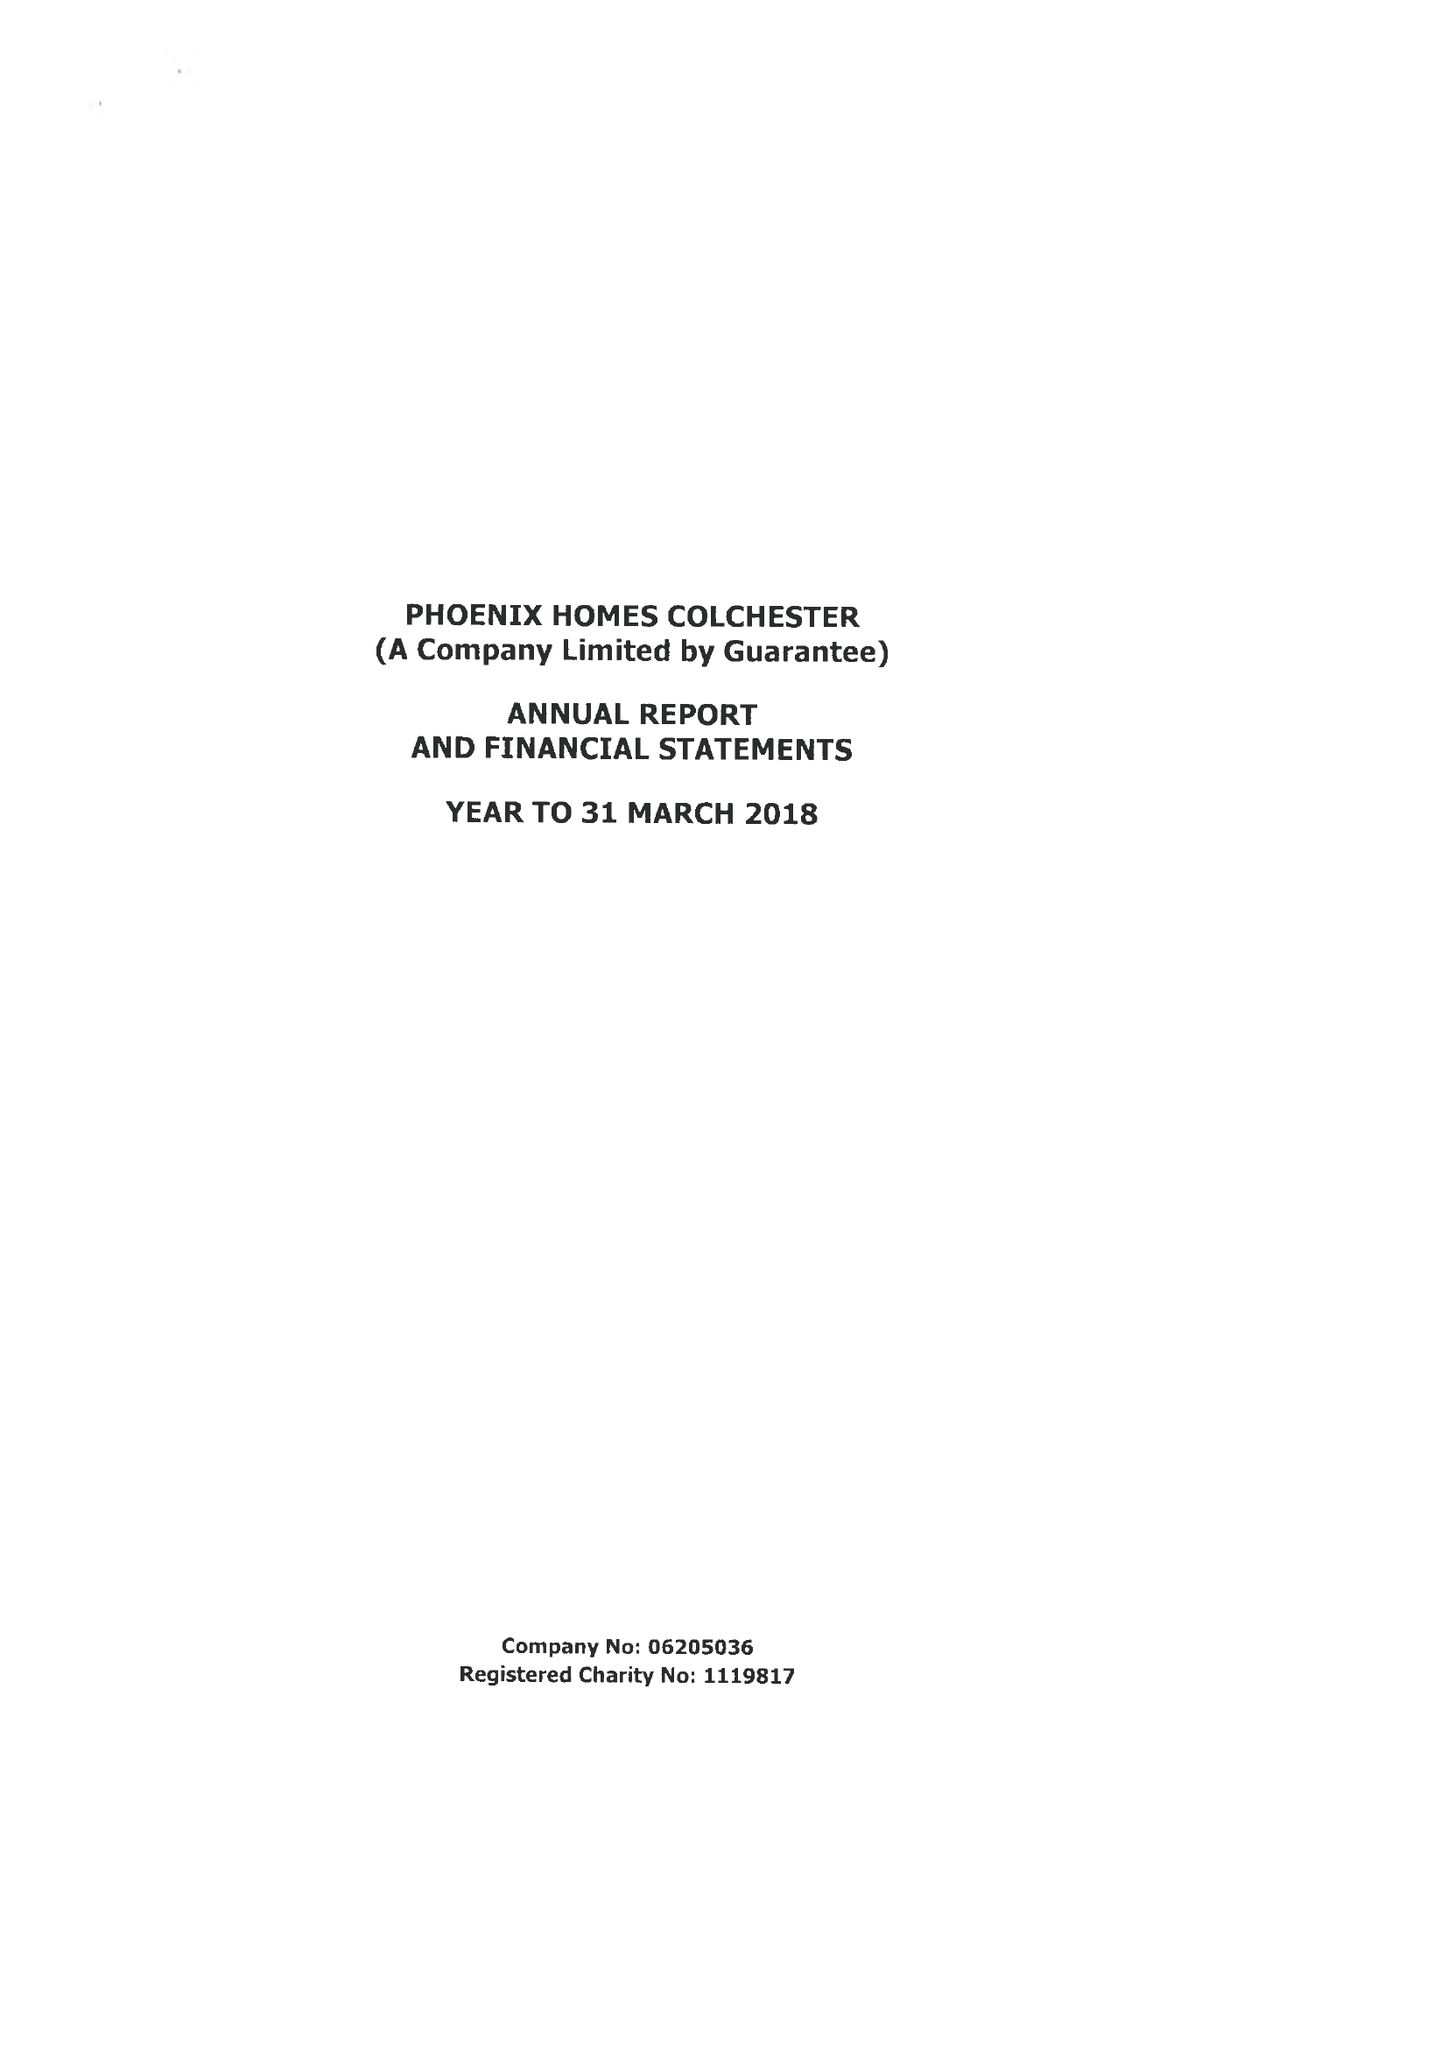What is the value for the address__post_town?
Answer the question using a single word or phrase. COLCHESTER 